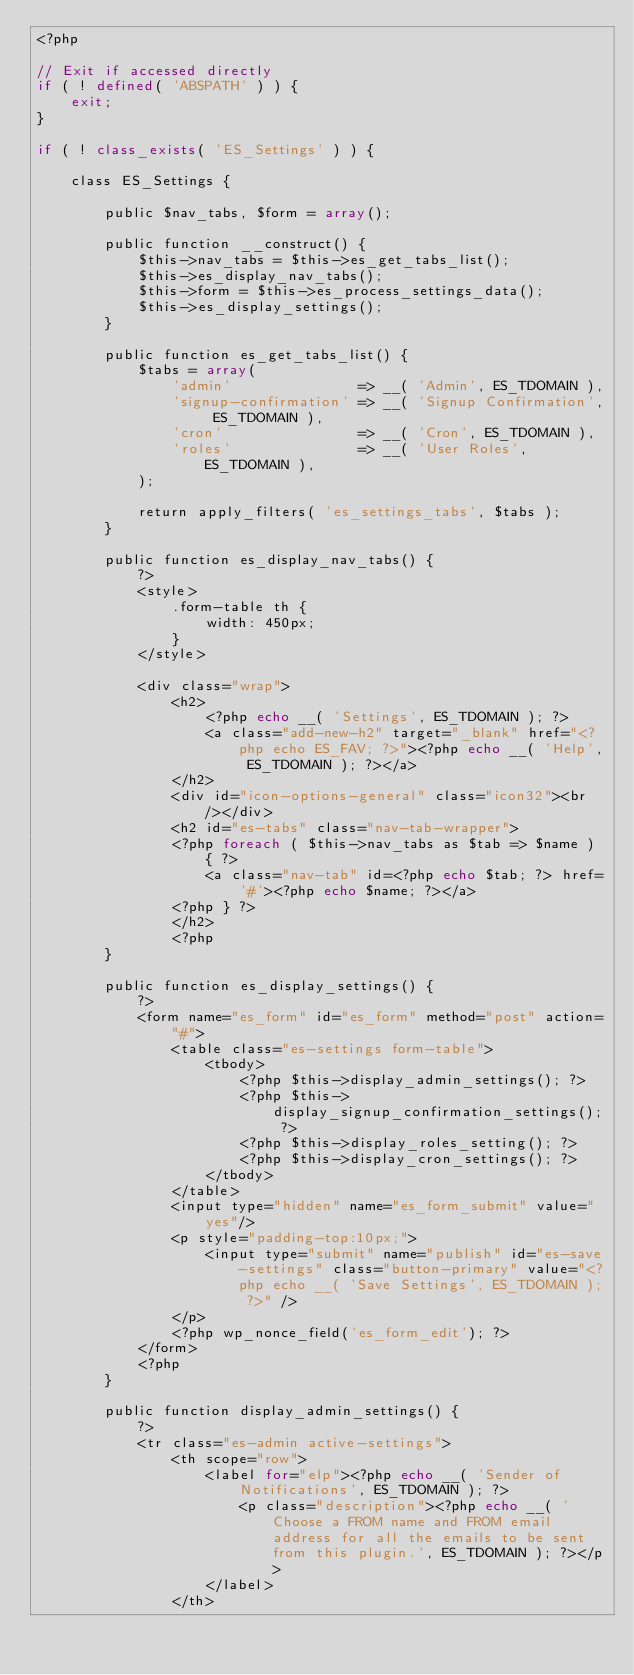<code> <loc_0><loc_0><loc_500><loc_500><_PHP_><?php

// Exit if accessed directly
if ( ! defined( 'ABSPATH' ) ) {
	exit;
}

if ( ! class_exists( 'ES_Settings' ) ) {

	class ES_Settings {

		public $nav_tabs, $form = array();

		public function __construct() {
			$this->nav_tabs = $this->es_get_tabs_list();
			$this->es_display_nav_tabs();
			$this->form = $this->es_process_settings_data();
			$this->es_display_settings();
		}

		public function es_get_tabs_list() {
			$tabs = array(
				'admin'				  => __( 'Admin', ES_TDOMAIN ),
				'signup-confirmation' => __( 'Signup Confirmation', ES_TDOMAIN ),
				'cron'	 			  => __( 'Cron', ES_TDOMAIN ),
				'roles' 			  => __( 'User Roles', ES_TDOMAIN ),
			);

			return apply_filters( 'es_settings_tabs', $tabs );
		}

		public function es_display_nav_tabs() {
			?>
			<style>
				.form-table th {
					width: 450px;
				}
			</style>

			<div class="wrap">
				<h2>
					<?php echo __( 'Settings', ES_TDOMAIN ); ?>
					<a class="add-new-h2" target="_blank" href="<?php echo ES_FAV; ?>"><?php echo __( 'Help', ES_TDOMAIN ); ?></a>
				</h2>
				<div id="icon-options-general" class="icon32"><br /></div>
				<h2 id="es-tabs" class="nav-tab-wrapper">
				<?php foreach ( $this->nav_tabs as $tab => $name ) { ?>
					<a class="nav-tab" id=<?php echo $tab; ?> href='#'><?php echo $name; ?></a>
				<?php } ?>
				</h2>
				<?php
		}

		public function es_display_settings() {
			?>
			<form name="es_form" id="es_form" method="post" action="#">
				<table class="es-settings form-table">
					<tbody>
						<?php $this->display_admin_settings(); ?>
						<?php $this->display_signup_confirmation_settings(); ?>
						<?php $this->display_roles_setting(); ?>
						<?php $this->display_cron_settings(); ?>
					</tbody>
				</table>
				<input type="hidden" name="es_form_submit" value="yes"/>
				<p style="padding-top:10px;">
					<input type="submit" name="publish" id="es-save-settings" class="button-primary" value="<?php echo __( 'Save Settings', ES_TDOMAIN ); ?>" />
				</p>
				<?php wp_nonce_field('es_form_edit'); ?>
			</form>
			<?php
		}

		public function display_admin_settings() {
			?>
			<tr class="es-admin active-settings">
				<th scope="row">
					<label for="elp"><?php echo __( 'Sender of Notifications', ES_TDOMAIN ); ?>
						<p class="description"><?php echo __( 'Choose a FROM name and FROM email address for all the emails to be sent from this plugin.', ES_TDOMAIN ); ?></p>
					</label>
				</th></code> 